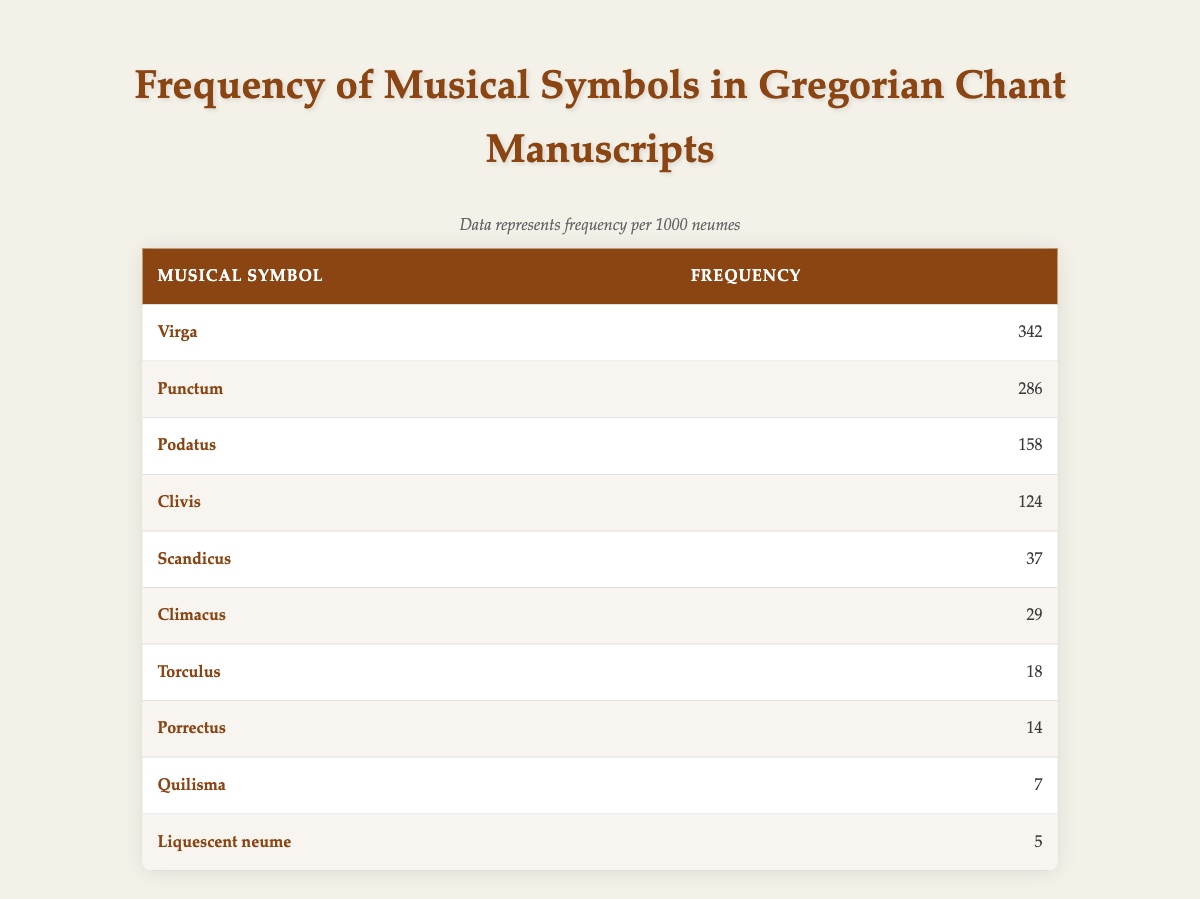What is the most frequently used musical symbol in Gregorian chant manuscripts? The table lists "Virga" as the musical symbol with the highest frequency, recorded at 342 occurrences per 1000 neumes.
Answer: Virga What is the frequency of "Punctum" in the table? The table specifies that "Punctum" appears 286 times per 1000 neumes.
Answer: 286 How many more times is "Podatus" used compared to "Climacus"? "Podatus" has a frequency of 158 while "Climacus" is at 29. The difference is calculated as 158 - 29 = 129.
Answer: 129 Is "Quilisma" more frequently used than "Porrectus"? According to the table, "Quilisma" has a frequency of 7 per 1000 neumes while "Porrectus" is at 14, which indicates that Quilisma is less frequent.
Answer: No What is the sum of frequencies for the three least frequent musical symbols? The three least frequent symbols are "Torculus" (18), "Porrectus" (14), and "Quilisma" (7). Their sum is calculated as 18 + 14 + 7 = 39.
Answer: 39 How does the frequency of "Scandicus" compare to the average frequency of the symbols listed in the table? The frequency of "Scandicus" is 37. To find the average, sum the frequencies: 342 + 286 + 158 + 124 + 37 + 29 + 18 + 14 + 7 + 5 = 1020 and divide by the count of symbols (10), giving an average of 1020 / 10 = 102. Since 37 is less than 102, Scandicus is below average.
Answer: Below average What is the difference in frequency between the most and the least frequently used symbols? The most frequently used symbol is "Virga" (342) and the least is "Liquescent neume" (5). The difference is calculated as 342 - 5 = 337.
Answer: 337 How many symbols have a frequency of 100 or more? From the table, the symbols with 100 or more frequencies are "Virga" (342), "Punctum" (286), "Podatus" (158), and "Clivis" (124). This totals to four symbols.
Answer: 4 Which symbol has the highest frequency and how many times does it occur per 1000 neumes? The symbol with the highest frequency is "Virga" at 342 occurrences per 1000 neumes.
Answer: 342 